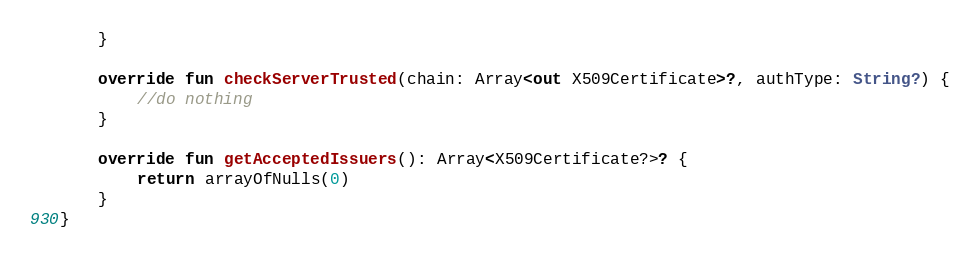Convert code to text. <code><loc_0><loc_0><loc_500><loc_500><_Kotlin_>    }

    override fun checkServerTrusted(chain: Array<out X509Certificate>?, authType: String?) {
        //do nothing
    }

    override fun getAcceptedIssuers(): Array<X509Certificate?>? {
        return arrayOfNulls(0)
    }
}
</code> 